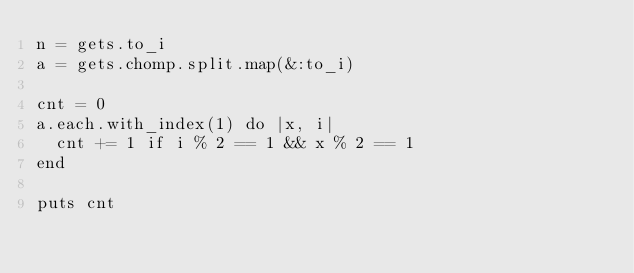<code> <loc_0><loc_0><loc_500><loc_500><_Ruby_>n = gets.to_i
a = gets.chomp.split.map(&:to_i)

cnt = 0
a.each.with_index(1) do |x, i|
  cnt += 1 if i % 2 == 1 && x % 2 == 1
end

puts cnt
</code> 